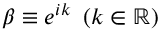<formula> <loc_0><loc_0><loc_500><loc_500>\beta \equiv e ^ { i k } \left ( k \in \mathbb { R } \right )</formula> 